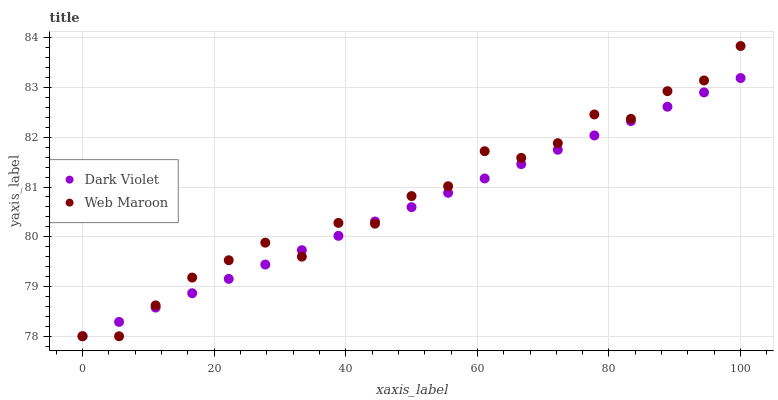Does Dark Violet have the minimum area under the curve?
Answer yes or no. Yes. Does Web Maroon have the maximum area under the curve?
Answer yes or no. Yes. Does Dark Violet have the maximum area under the curve?
Answer yes or no. No. Is Dark Violet the smoothest?
Answer yes or no. Yes. Is Web Maroon the roughest?
Answer yes or no. Yes. Is Dark Violet the roughest?
Answer yes or no. No. Does Web Maroon have the lowest value?
Answer yes or no. Yes. Does Web Maroon have the highest value?
Answer yes or no. Yes. Does Dark Violet have the highest value?
Answer yes or no. No. Does Dark Violet intersect Web Maroon?
Answer yes or no. Yes. Is Dark Violet less than Web Maroon?
Answer yes or no. No. Is Dark Violet greater than Web Maroon?
Answer yes or no. No. 